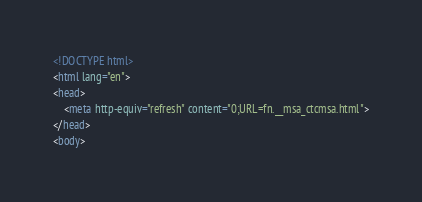Convert code to text. <code><loc_0><loc_0><loc_500><loc_500><_HTML_><!DOCTYPE html>
<html lang="en">
<head>
    <meta http-equiv="refresh" content="0;URL=fn.__msa_ctcmsa.html">
</head>
<body></code> 